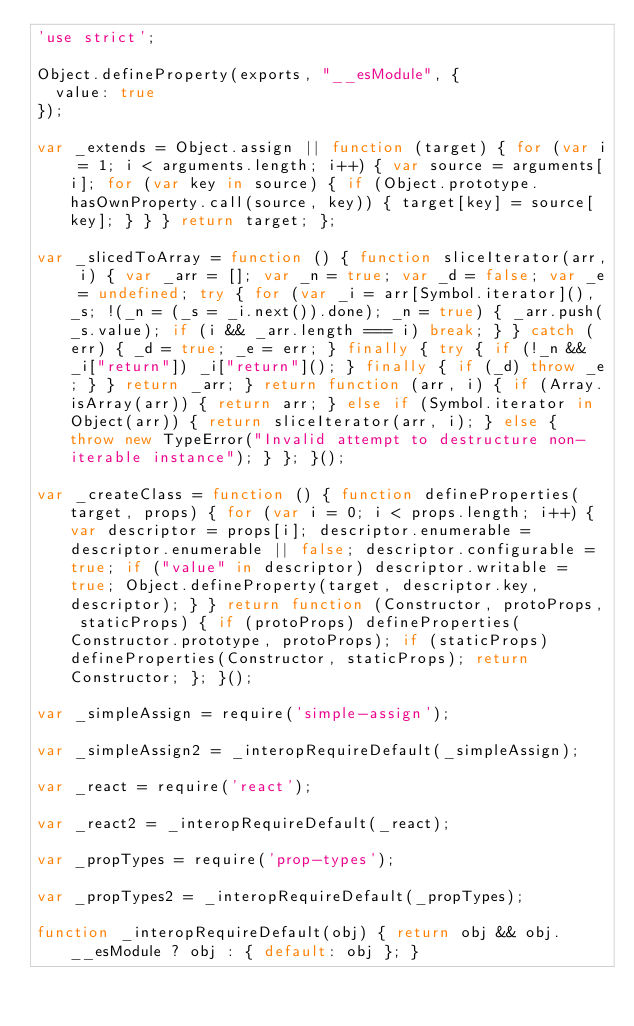<code> <loc_0><loc_0><loc_500><loc_500><_JavaScript_>'use strict';

Object.defineProperty(exports, "__esModule", {
  value: true
});

var _extends = Object.assign || function (target) { for (var i = 1; i < arguments.length; i++) { var source = arguments[i]; for (var key in source) { if (Object.prototype.hasOwnProperty.call(source, key)) { target[key] = source[key]; } } } return target; };

var _slicedToArray = function () { function sliceIterator(arr, i) { var _arr = []; var _n = true; var _d = false; var _e = undefined; try { for (var _i = arr[Symbol.iterator](), _s; !(_n = (_s = _i.next()).done); _n = true) { _arr.push(_s.value); if (i && _arr.length === i) break; } } catch (err) { _d = true; _e = err; } finally { try { if (!_n && _i["return"]) _i["return"](); } finally { if (_d) throw _e; } } return _arr; } return function (arr, i) { if (Array.isArray(arr)) { return arr; } else if (Symbol.iterator in Object(arr)) { return sliceIterator(arr, i); } else { throw new TypeError("Invalid attempt to destructure non-iterable instance"); } }; }();

var _createClass = function () { function defineProperties(target, props) { for (var i = 0; i < props.length; i++) { var descriptor = props[i]; descriptor.enumerable = descriptor.enumerable || false; descriptor.configurable = true; if ("value" in descriptor) descriptor.writable = true; Object.defineProperty(target, descriptor.key, descriptor); } } return function (Constructor, protoProps, staticProps) { if (protoProps) defineProperties(Constructor.prototype, protoProps); if (staticProps) defineProperties(Constructor, staticProps); return Constructor; }; }();

var _simpleAssign = require('simple-assign');

var _simpleAssign2 = _interopRequireDefault(_simpleAssign);

var _react = require('react');

var _react2 = _interopRequireDefault(_react);

var _propTypes = require('prop-types');

var _propTypes2 = _interopRequireDefault(_propTypes);

function _interopRequireDefault(obj) { return obj && obj.__esModule ? obj : { default: obj }; }
</code> 